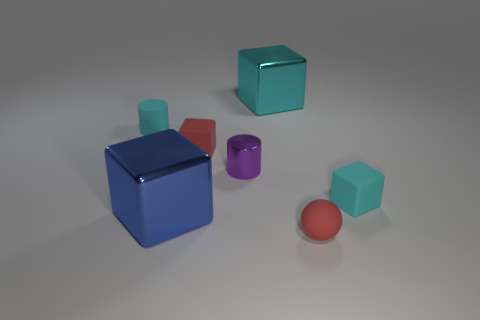The big thing that is in front of the large cyan metallic block is what color?
Your response must be concise. Blue. There is a small cube to the left of the matte thing right of the sphere; what is its color?
Offer a very short reply. Red. What color is the ball that is the same size as the purple object?
Give a very brief answer. Red. How many things are behind the blue cube and to the left of the red cube?
Keep it short and to the point. 1. There is a rubber thing that is the same color as the rubber ball; what shape is it?
Offer a terse response. Cube. There is a block that is left of the big cyan thing and behind the big blue cube; what material is it made of?
Your answer should be very brief. Rubber. Is the number of matte cubes that are on the left side of the big blue metallic cube less than the number of small rubber cubes that are behind the red matte block?
Your answer should be compact. No. What is the size of the cyan block that is made of the same material as the large blue block?
Keep it short and to the point. Large. Is there anything else of the same color as the sphere?
Keep it short and to the point. Yes. Does the large blue object have the same material as the tiny cylinder behind the small red block?
Provide a succinct answer. No. 